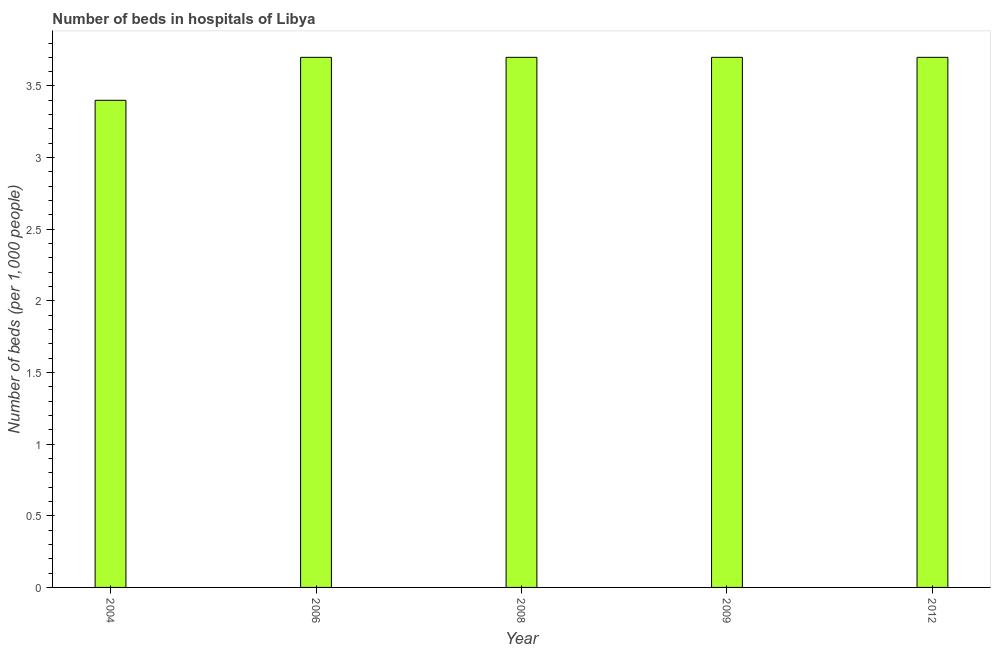Does the graph contain any zero values?
Your answer should be compact. No. Does the graph contain grids?
Make the answer very short. No. What is the title of the graph?
Ensure brevity in your answer.  Number of beds in hospitals of Libya. What is the label or title of the Y-axis?
Give a very brief answer. Number of beds (per 1,0 people). What is the number of hospital beds in 2004?
Offer a terse response. 3.4. Across all years, what is the maximum number of hospital beds?
Ensure brevity in your answer.  3.7. In which year was the number of hospital beds minimum?
Give a very brief answer. 2004. What is the difference between the number of hospital beds in 2008 and 2009?
Your answer should be very brief. 0. What is the average number of hospital beds per year?
Ensure brevity in your answer.  3.64. What is the median number of hospital beds?
Your response must be concise. 3.7. What is the ratio of the number of hospital beds in 2009 to that in 2012?
Ensure brevity in your answer.  1. Is the number of hospital beds in 2006 less than that in 2012?
Your answer should be very brief. No. What is the difference between the highest and the second highest number of hospital beds?
Ensure brevity in your answer.  0. Is the sum of the number of hospital beds in 2004 and 2006 greater than the maximum number of hospital beds across all years?
Keep it short and to the point. Yes. What is the difference between the highest and the lowest number of hospital beds?
Ensure brevity in your answer.  0.3. In how many years, is the number of hospital beds greater than the average number of hospital beds taken over all years?
Your answer should be compact. 4. How many bars are there?
Your answer should be very brief. 5. Are all the bars in the graph horizontal?
Make the answer very short. No. What is the difference between the Number of beds (per 1,000 people) in 2004 and 2008?
Provide a short and direct response. -0.3. What is the difference between the Number of beds (per 1,000 people) in 2004 and 2012?
Keep it short and to the point. -0.3. What is the difference between the Number of beds (per 1,000 people) in 2006 and 2008?
Offer a very short reply. 0. What is the difference between the Number of beds (per 1,000 people) in 2006 and 2009?
Ensure brevity in your answer.  0. What is the difference between the Number of beds (per 1,000 people) in 2006 and 2012?
Your answer should be very brief. 0. What is the difference between the Number of beds (per 1,000 people) in 2009 and 2012?
Your answer should be compact. 0. What is the ratio of the Number of beds (per 1,000 people) in 2004 to that in 2006?
Give a very brief answer. 0.92. What is the ratio of the Number of beds (per 1,000 people) in 2004 to that in 2008?
Your answer should be compact. 0.92. What is the ratio of the Number of beds (per 1,000 people) in 2004 to that in 2009?
Keep it short and to the point. 0.92. What is the ratio of the Number of beds (per 1,000 people) in 2004 to that in 2012?
Your response must be concise. 0.92. What is the ratio of the Number of beds (per 1,000 people) in 2006 to that in 2008?
Provide a short and direct response. 1. What is the ratio of the Number of beds (per 1,000 people) in 2006 to that in 2009?
Give a very brief answer. 1. 